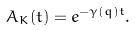<formula> <loc_0><loc_0><loc_500><loc_500>A _ { K } ( t ) = e ^ { - \gamma ( q ) t } .</formula> 